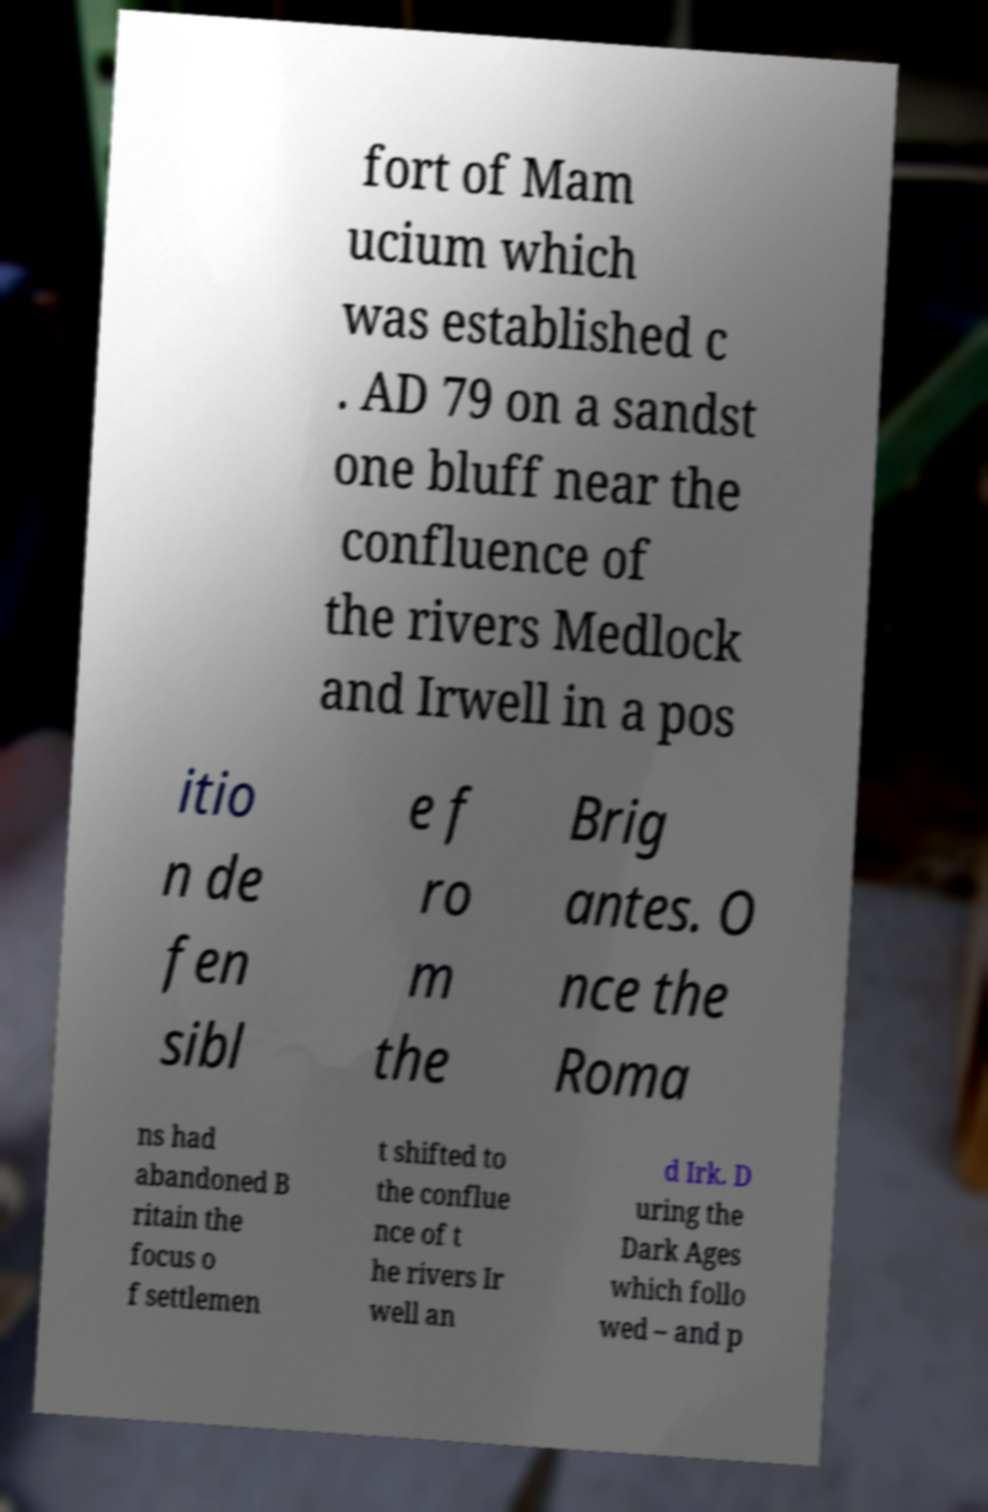Please read and relay the text visible in this image. What does it say? fort of Mam ucium which was established c . AD 79 on a sandst one bluff near the confluence of the rivers Medlock and Irwell in a pos itio n de fen sibl e f ro m the Brig antes. O nce the Roma ns had abandoned B ritain the focus o f settlemen t shifted to the conflue nce of t he rivers Ir well an d Irk. D uring the Dark Ages which follo wed – and p 